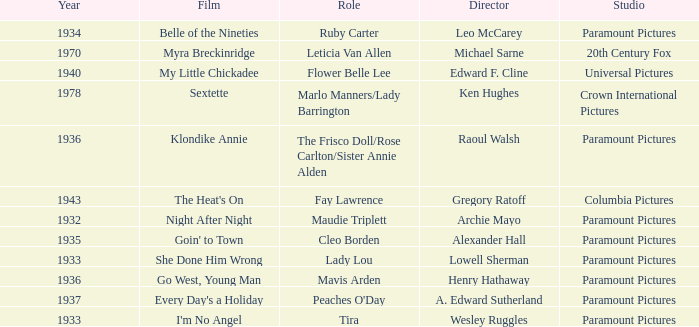What is the Year of the Film Klondike Annie? 1936.0. Could you parse the entire table as a dict? {'header': ['Year', 'Film', 'Role', 'Director', 'Studio'], 'rows': [['1934', 'Belle of the Nineties', 'Ruby Carter', 'Leo McCarey', 'Paramount Pictures'], ['1970', 'Myra Breckinridge', 'Leticia Van Allen', 'Michael Sarne', '20th Century Fox'], ['1940', 'My Little Chickadee', 'Flower Belle Lee', 'Edward F. Cline', 'Universal Pictures'], ['1978', 'Sextette', 'Marlo Manners/Lady Barrington', 'Ken Hughes', 'Crown International Pictures'], ['1936', 'Klondike Annie', 'The Frisco Doll/Rose Carlton/Sister Annie Alden', 'Raoul Walsh', 'Paramount Pictures'], ['1943', "The Heat's On", 'Fay Lawrence', 'Gregory Ratoff', 'Columbia Pictures'], ['1932', 'Night After Night', 'Maudie Triplett', 'Archie Mayo', 'Paramount Pictures'], ['1935', "Goin' to Town", 'Cleo Borden', 'Alexander Hall', 'Paramount Pictures'], ['1933', 'She Done Him Wrong', 'Lady Lou', 'Lowell Sherman', 'Paramount Pictures'], ['1936', 'Go West, Young Man', 'Mavis Arden', 'Henry Hathaway', 'Paramount Pictures'], ['1937', "Every Day's a Holiday", "Peaches O'Day", 'A. Edward Sutherland', 'Paramount Pictures'], ['1933', "I'm No Angel", 'Tira', 'Wesley Ruggles', 'Paramount Pictures']]} 